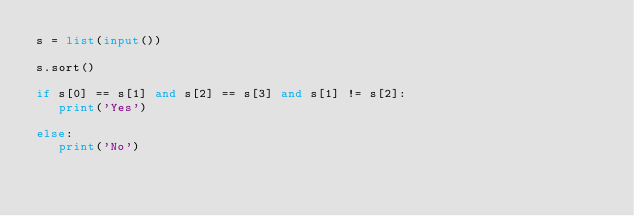Convert code to text. <code><loc_0><loc_0><loc_500><loc_500><_Python_>s = list(input())

s.sort()

if s[0] == s[1] and s[2] == s[3] and s[1] != s[2]:
   print('Yes')

else:
   print('No')  
    </code> 